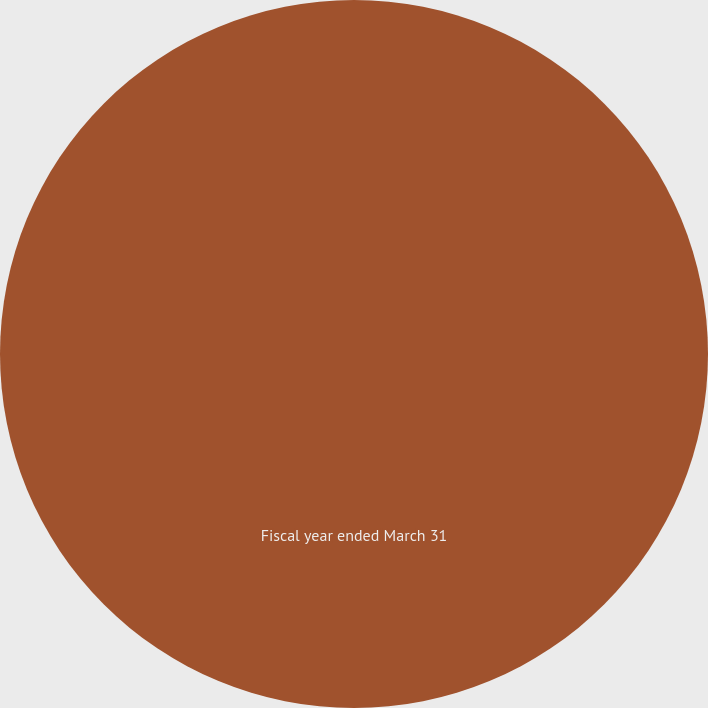Convert chart. <chart><loc_0><loc_0><loc_500><loc_500><pie_chart><fcel>Fiscal year ended March 31<nl><fcel>100.0%<nl></chart> 